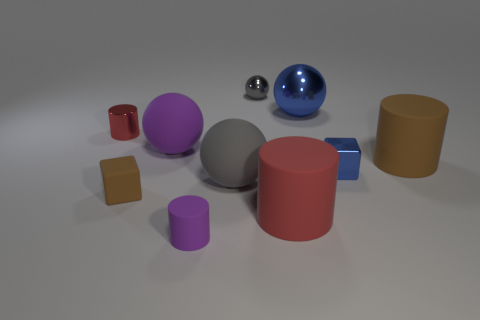Subtract 1 spheres. How many spheres are left? 3 Subtract all spheres. How many objects are left? 6 Add 8 small purple cylinders. How many small purple cylinders are left? 9 Add 5 shiny cylinders. How many shiny cylinders exist? 6 Subtract 2 red cylinders. How many objects are left? 8 Subtract all brown rubber blocks. Subtract all tiny brown matte blocks. How many objects are left? 8 